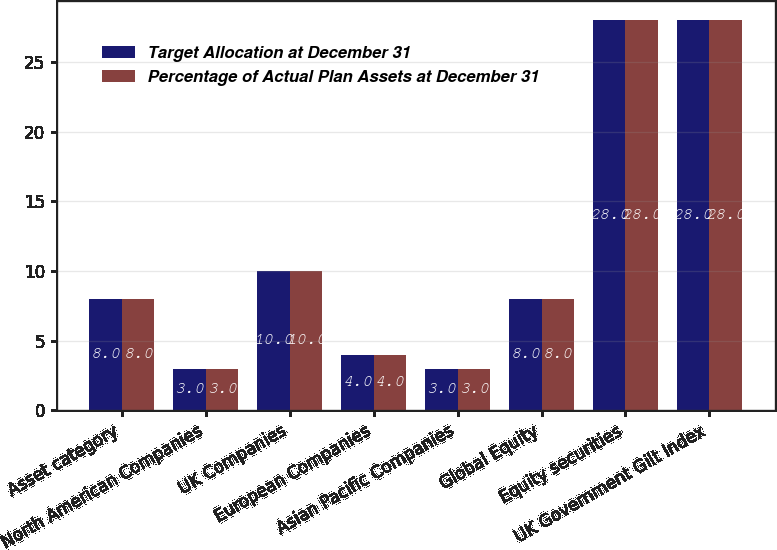Convert chart. <chart><loc_0><loc_0><loc_500><loc_500><stacked_bar_chart><ecel><fcel>Asset category<fcel>North American Companies<fcel>UK Companies<fcel>European Companies<fcel>Asian Pacific Companies<fcel>Global Equity<fcel>Equity securities<fcel>UK Government Gilt Index<nl><fcel>Target Allocation at December 31<fcel>8<fcel>3<fcel>10<fcel>4<fcel>3<fcel>8<fcel>28<fcel>28<nl><fcel>Percentage of Actual Plan Assets at December 31<fcel>8<fcel>3<fcel>10<fcel>4<fcel>3<fcel>8<fcel>28<fcel>28<nl></chart> 